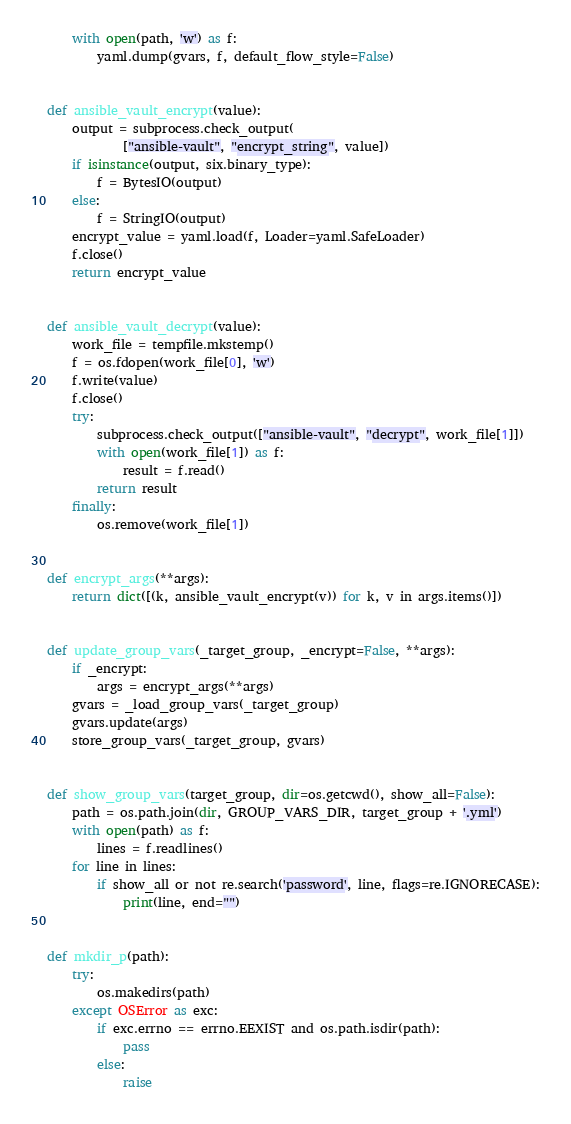Convert code to text. <code><loc_0><loc_0><loc_500><loc_500><_Python_>    with open(path, 'w') as f:
        yaml.dump(gvars, f, default_flow_style=False)


def ansible_vault_encrypt(value):
    output = subprocess.check_output(
            ["ansible-vault", "encrypt_string", value])
    if isinstance(output, six.binary_type):
        f = BytesIO(output)
    else:
        f = StringIO(output)
    encrypt_value = yaml.load(f, Loader=yaml.SafeLoader)
    f.close()
    return encrypt_value


def ansible_vault_decrypt(value):
    work_file = tempfile.mkstemp()
    f = os.fdopen(work_file[0], 'w')
    f.write(value)
    f.close()
    try:
        subprocess.check_output(["ansible-vault", "decrypt", work_file[1]])
        with open(work_file[1]) as f:
            result = f.read()
        return result
    finally:
        os.remove(work_file[1])


def encrypt_args(**args):
    return dict([(k, ansible_vault_encrypt(v)) for k, v in args.items()])


def update_group_vars(_target_group, _encrypt=False, **args):
    if _encrypt:
        args = encrypt_args(**args)
    gvars = _load_group_vars(_target_group)
    gvars.update(args)
    store_group_vars(_target_group, gvars)


def show_group_vars(target_group, dir=os.getcwd(), show_all=False):
    path = os.path.join(dir, GROUP_VARS_DIR, target_group + '.yml')
    with open(path) as f:
        lines = f.readlines()
    for line in lines:
        if show_all or not re.search('password', line, flags=re.IGNORECASE):
            print(line, end="")


def mkdir_p(path):
    try:
        os.makedirs(path)
    except OSError as exc:
        if exc.errno == errno.EEXIST and os.path.isdir(path):
            pass
        else:
            raise
</code> 